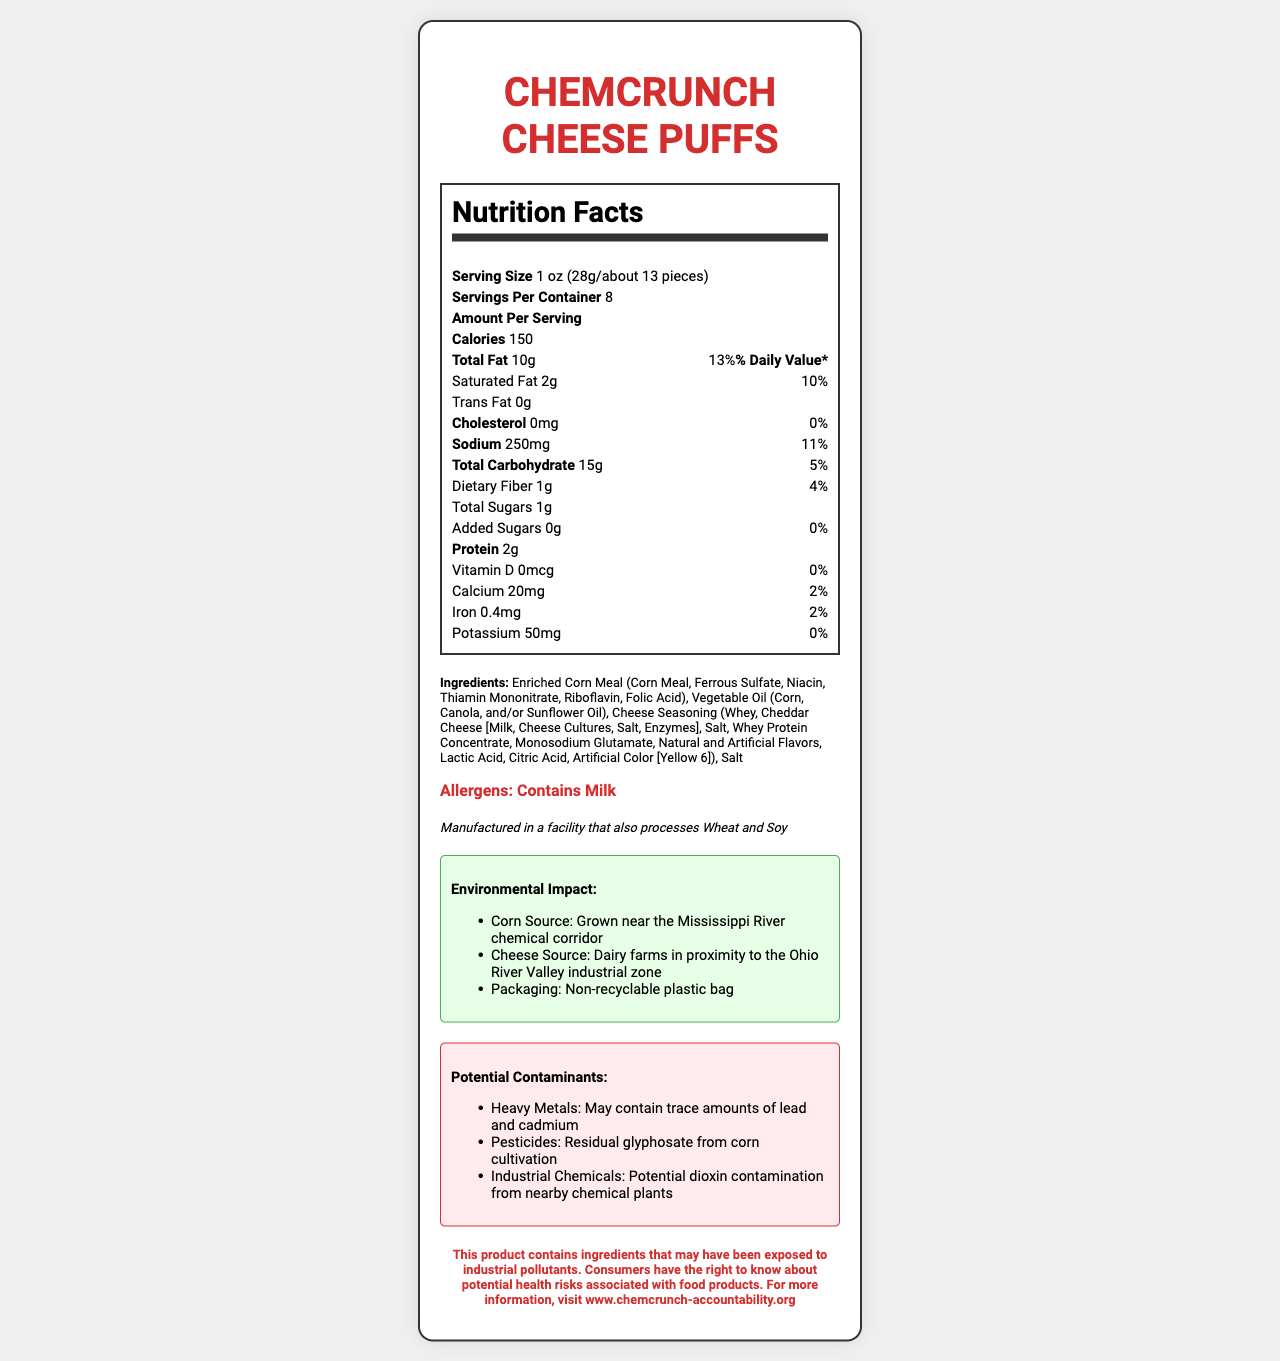what is the serving size of ChemCrunch Cheese Puffs? The serving size is explicitly stated as "1 oz (28g/about 13 pieces)" in the Nutrition Facts section of the document.
Answer: 1 oz (28g/about 13 pieces) how many servings are in the package? The number of servings per container is mentioned as 8.
Answer: 8 what is the total amount of fat per serving? The total fat content is listed as "10g" under the "Amount Per Serving" section.
Answer: 10g how much sodium is in one serving? The sodium content for one serving is indicated as 250mg.
Answer: 250mg what are the main ingredients in ChemCrunch Cheese Puffs? The main ingredients are listed in the Ingredients section: "Enriched Corn Meal (Corn Meal, Ferrous Sulfate, Niacin, Thiamin Mononitrate, Riboflavin, Folic Acid), Vegetable Oil (Corn, Canola, and/or Sunflower Oil), Cheese Seasoning (Whey, Cheddar Cheese [Milk, Cheese Cultures, Salt, Enzymes], Salt, Whey Protein Concentrate, Monosodium Glutamate, Natural and Artificial Flavors, Lactic Acid, Citric Acid, Artificial Color [Yellow 6]), Salt".
Answer: Enriched Corn Meal, Vegetable Oil, Cheese Seasoning, Salt which potential contaminants are mentioned? A. Lead and cadmium B. Residual glyphosate C. Industrial chemicals D. All of the above All mentioned contaminants (heavy metals like lead and cadmium, residual glyphosate, and potential industrial chemicals) are listed in the Potential Contaminants section.
Answer: D where is the corn used in ChemCrunch Cheese Puffs sourced from? A. California B. Near the Mississippi River C. Midwest D. Ohio Valley The corn source is specified as "Grown near the Mississippi River chemical corridor" in the Environmental Impact section.
Answer: B are these snacks made in a facility that processes soy? The legal disclaimer clearly states that they are "Manufactured in a facility that also processes Wheat and Soy".
Answer: Yes can the packaging be recycled? The packaging is explicitly described as "Non-recyclable plastic bag" in the Environmental Impact section.
Answer: No summarize the potential health risks mentioned in the document. The Potential Contaminants section specifies that the product may contain heavy metals, pesticides, and industrial chemicals, which can pose health risks. The legal notice at the end informs consumers about these potential health hazards.
Answer: The document indicates potential health risks due to the presence of heavy metals (lead and cadmium), residual glyphosate from corn cultivation, and potential dioxin contamination from nearby chemical plants. Consumers are warned about these contaminants. are there any added sugars in ChemCrunch Cheese Puffs? The amount of added sugars is listed as 0g in the Nutrition Facts section.
Answer: No what is the total carbohydrate percentage of daily value? The total carbohydrate daily value percentage is given as 5% in the Nutrition Facts section.
Answer: 5% does the document provide specific information on the source of the cheese? The Environmental Impact section mentions that the cheese is sourced from "Dairy farms in proximity to the Ohio River Valley industrial zone".
Answer: Yes how is the nutrient information visually structured in the document? The Nutrition Facts are presented in a structured way with clear headings and values aligned for easy reading.
Answer: It is structured in a table-like format with bold headings for each nutrient and corresponding values including the amount per serving and % daily value. is there any indication if the product is healthy or unhealthy? The document provides the nutritional content and potential contaminants but does not make a direct indication of whether the product is overall healthy or unhealthy.
Answer: Not enough information 